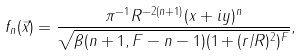Convert formula to latex. <formula><loc_0><loc_0><loc_500><loc_500>f _ { n } ( \vec { x } ) = \frac { \pi ^ { - 1 } R ^ { - 2 ( n + 1 ) } ( x + i y ) ^ { n } } { \sqrt { \beta ( n + 1 , F - n - 1 ) ( 1 + ( r / R ) ^ { 2 } ) ^ { F } } } ,</formula> 